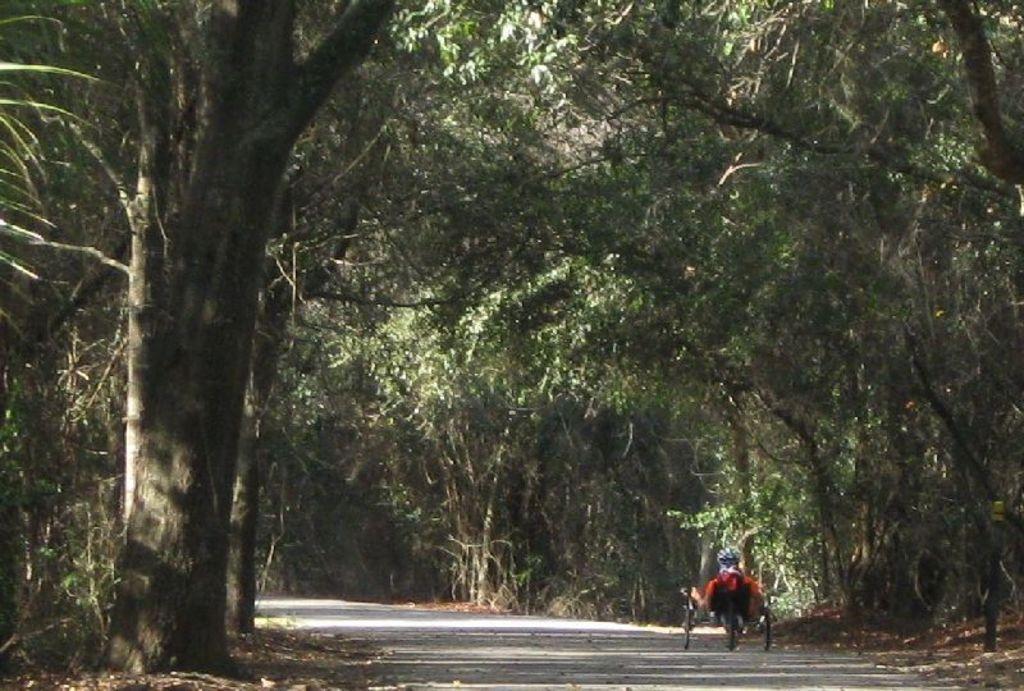How would you summarize this image in a sentence or two? In this image I can see trees and there is an object on the road. 